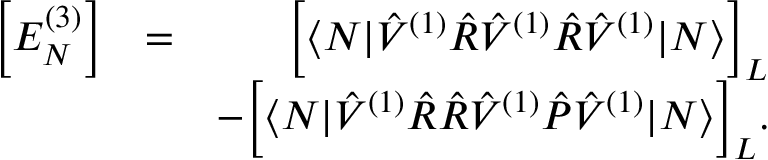<formula> <loc_0><loc_0><loc_500><loc_500>\begin{array} { r l r } { \left [ E _ { N } ^ { ( 3 ) } \right ] } & { = } & { \left [ \langle N | \hat { V } ^ { ( 1 ) } \hat { R } \hat { V } ^ { ( 1 ) } \hat { R } \hat { V } ^ { ( 1 ) } | N \rangle \right ] _ { L } } \\ & { - \left [ \langle N | \hat { V } ^ { ( 1 ) } \hat { R } \hat { R } \hat { V } ^ { ( 1 ) } \hat { P } \hat { V } ^ { ( 1 ) } | N \rangle \right ] _ { L } . } \end{array}</formula> 